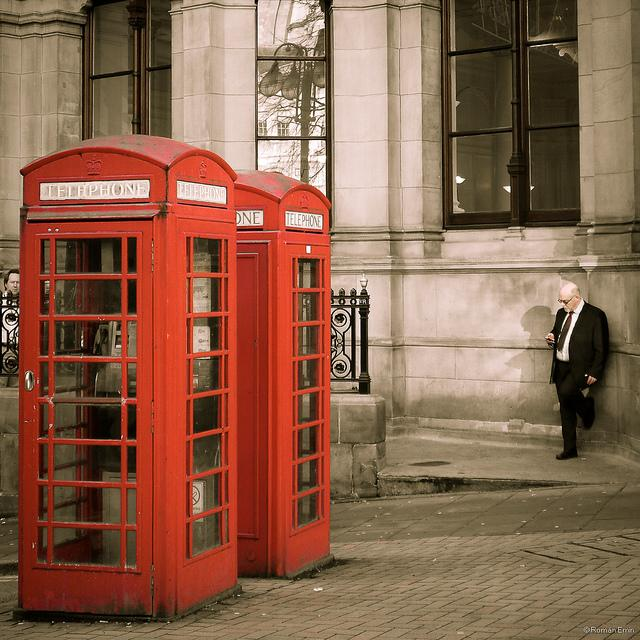If the gentleman here in the suit wants to call his sweetheart where will he do it? Please explain your reasoning. phone booth. The man might not have a cellphone but he can for sure make a call from the phone booth. 